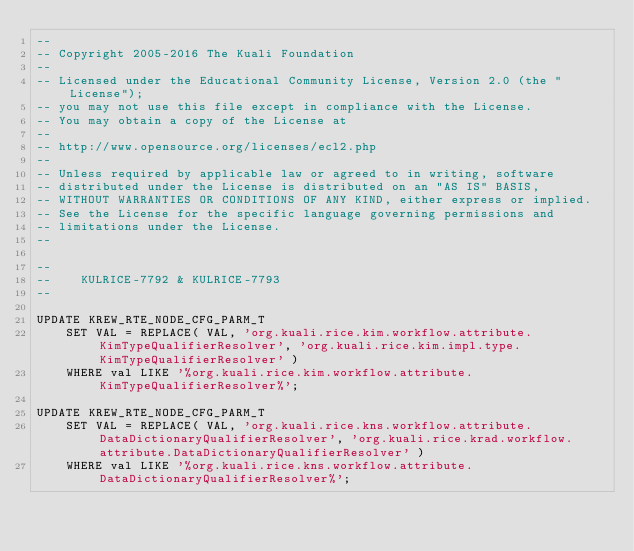<code> <loc_0><loc_0><loc_500><loc_500><_SQL_>--
-- Copyright 2005-2016 The Kuali Foundation
--
-- Licensed under the Educational Community License, Version 2.0 (the "License");
-- you may not use this file except in compliance with the License.
-- You may obtain a copy of the License at
--
-- http://www.opensource.org/licenses/ecl2.php
--
-- Unless required by applicable law or agreed to in writing, software
-- distributed under the License is distributed on an "AS IS" BASIS,
-- WITHOUT WARRANTIES OR CONDITIONS OF ANY KIND, either express or implied.
-- See the License for the specific language governing permissions and
-- limitations under the License.
--

--
--    KULRICE-7792 & KULRICE-7793
--

UPDATE KREW_RTE_NODE_CFG_PARM_T
    SET VAL = REPLACE( VAL, 'org.kuali.rice.kim.workflow.attribute.KimTypeQualifierResolver', 'org.kuali.rice.kim.impl.type.KimTypeQualifierResolver' )
    WHERE val LIKE '%org.kuali.rice.kim.workflow.attribute.KimTypeQualifierResolver%';

UPDATE KREW_RTE_NODE_CFG_PARM_T
    SET VAL = REPLACE( VAL, 'org.kuali.rice.kns.workflow.attribute.DataDictionaryQualifierResolver', 'org.kuali.rice.krad.workflow.attribute.DataDictionaryQualifierResolver' )
    WHERE val LIKE '%org.kuali.rice.kns.workflow.attribute.DataDictionaryQualifierResolver%';
</code> 